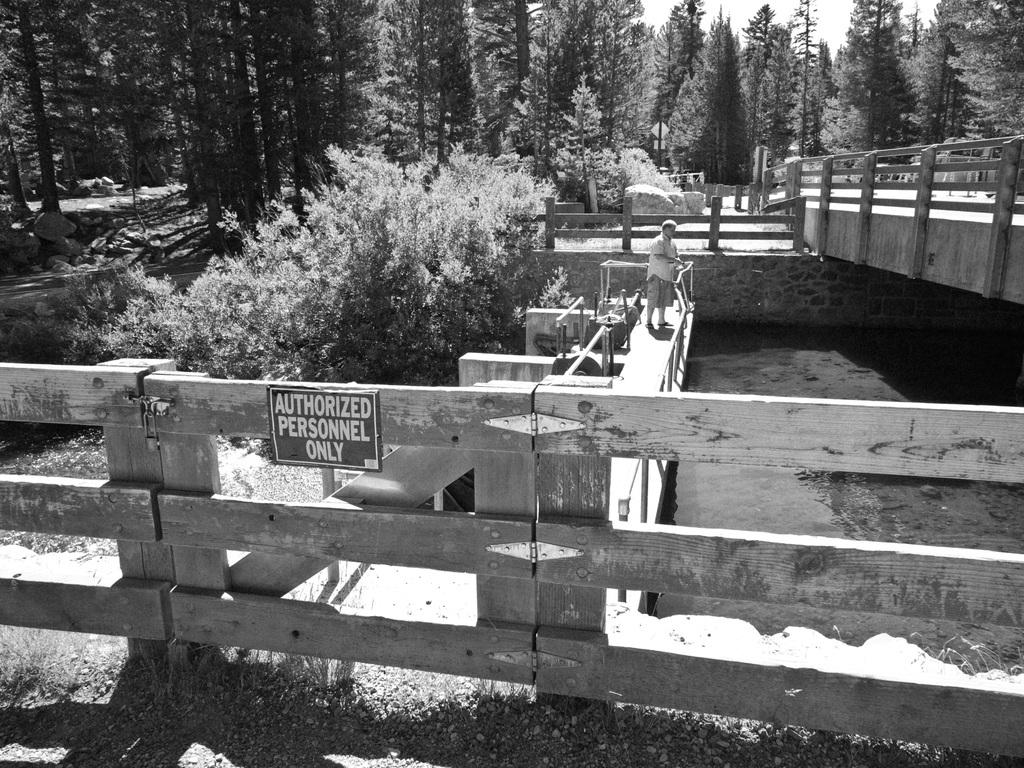What can be seen in the sky in the image? The sky is visible in the image. What type of vegetation is present in the image? There are trees and bushes in the image. What type of barrier is in the image? There is a wooden fence in the image. What natural element is visible in the image? Water is visible in the image. What is the person in the image doing? There is a person standing on a bridge in the image. What type of calculator is the person using on the bridge in the image? There is no calculator present in the image; the person is simply standing on the bridge. What color is the person's nose in the image? The image does not provide enough detail to determine the color of the person's nose. 